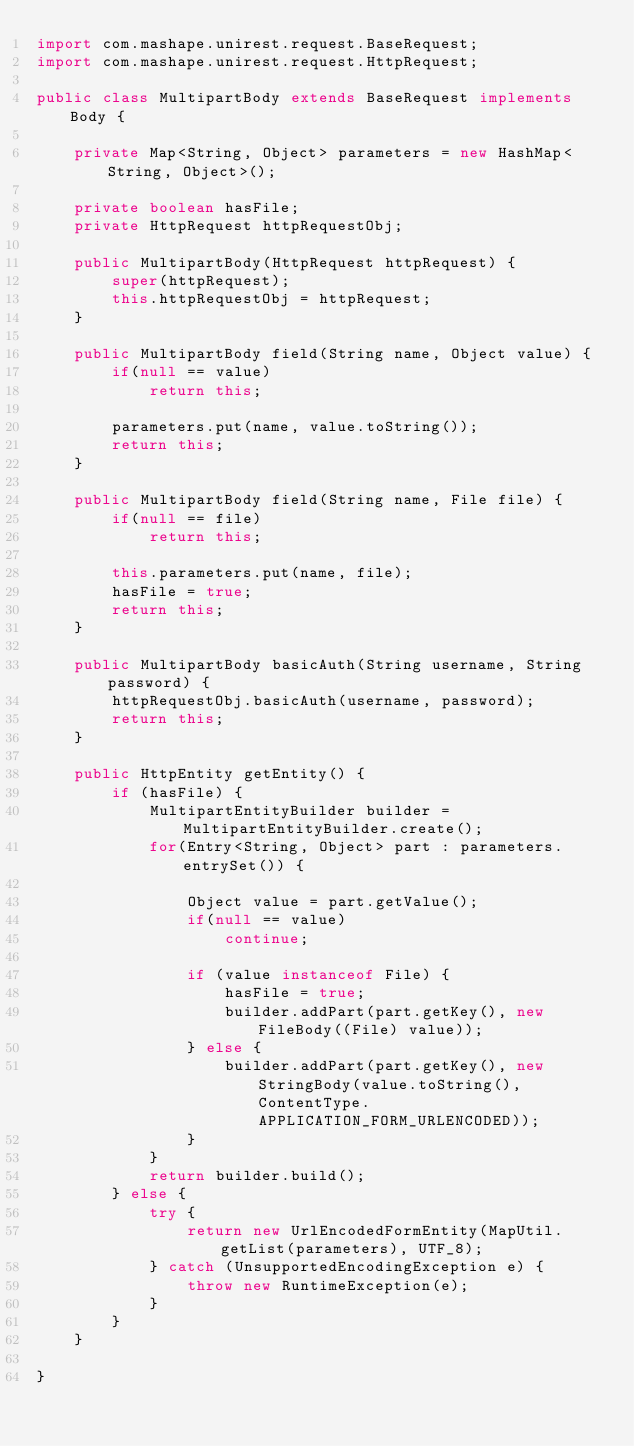<code> <loc_0><loc_0><loc_500><loc_500><_Java_>import com.mashape.unirest.request.BaseRequest;
import com.mashape.unirest.request.HttpRequest;

public class MultipartBody extends BaseRequest implements Body {

	private Map<String, Object> parameters = new HashMap<String, Object>();

	private boolean hasFile;
	private HttpRequest httpRequestObj;
	
	public MultipartBody(HttpRequest httpRequest) {
		super(httpRequest);
		this.httpRequestObj = httpRequest;
	}
	
	public MultipartBody field(String name, Object value) {
        if(null == value)
            return this;

		parameters.put(name, value.toString());
		return this;
	}
	
	public MultipartBody field(String name, File file) {
        if(null == file)
            return this;

		this.parameters.put(name, file);
		hasFile = true;
		return this;
	}
	
	public MultipartBody basicAuth(String username, String password) {
		httpRequestObj.basicAuth(username, password);
		return this;
	}
	
	public HttpEntity getEntity() {
		if (hasFile) {
			MultipartEntityBuilder builder = MultipartEntityBuilder.create();
			for(Entry<String, Object> part : parameters.entrySet()) {

                Object value = part.getValue();
                if(null == value)
                    continue;

                if (value instanceof File) {
					hasFile = true;
					builder.addPart(part.getKey(), new FileBody((File) value));
				} else {
					builder.addPart(part.getKey(), new StringBody(value.toString(), ContentType.APPLICATION_FORM_URLENCODED));
				}
			}
			return builder.build();
		} else {
			try {
				return new UrlEncodedFormEntity(MapUtil.getList(parameters), UTF_8);
			} catch (UnsupportedEncodingException e) {
				throw new RuntimeException(e);
			}
		}
	}

}
</code> 